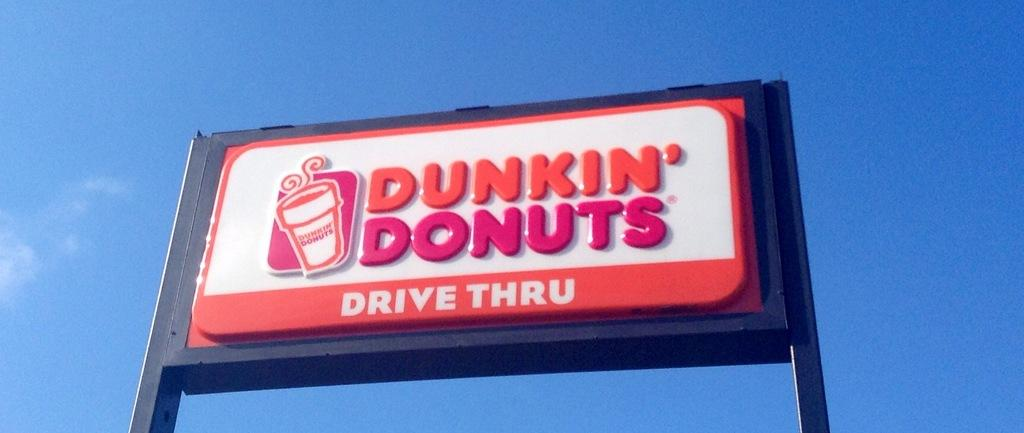<image>
Render a clear and concise summary of the photo. A Dunkin' Donuts Drive Thru sign is set against a blue sky. 